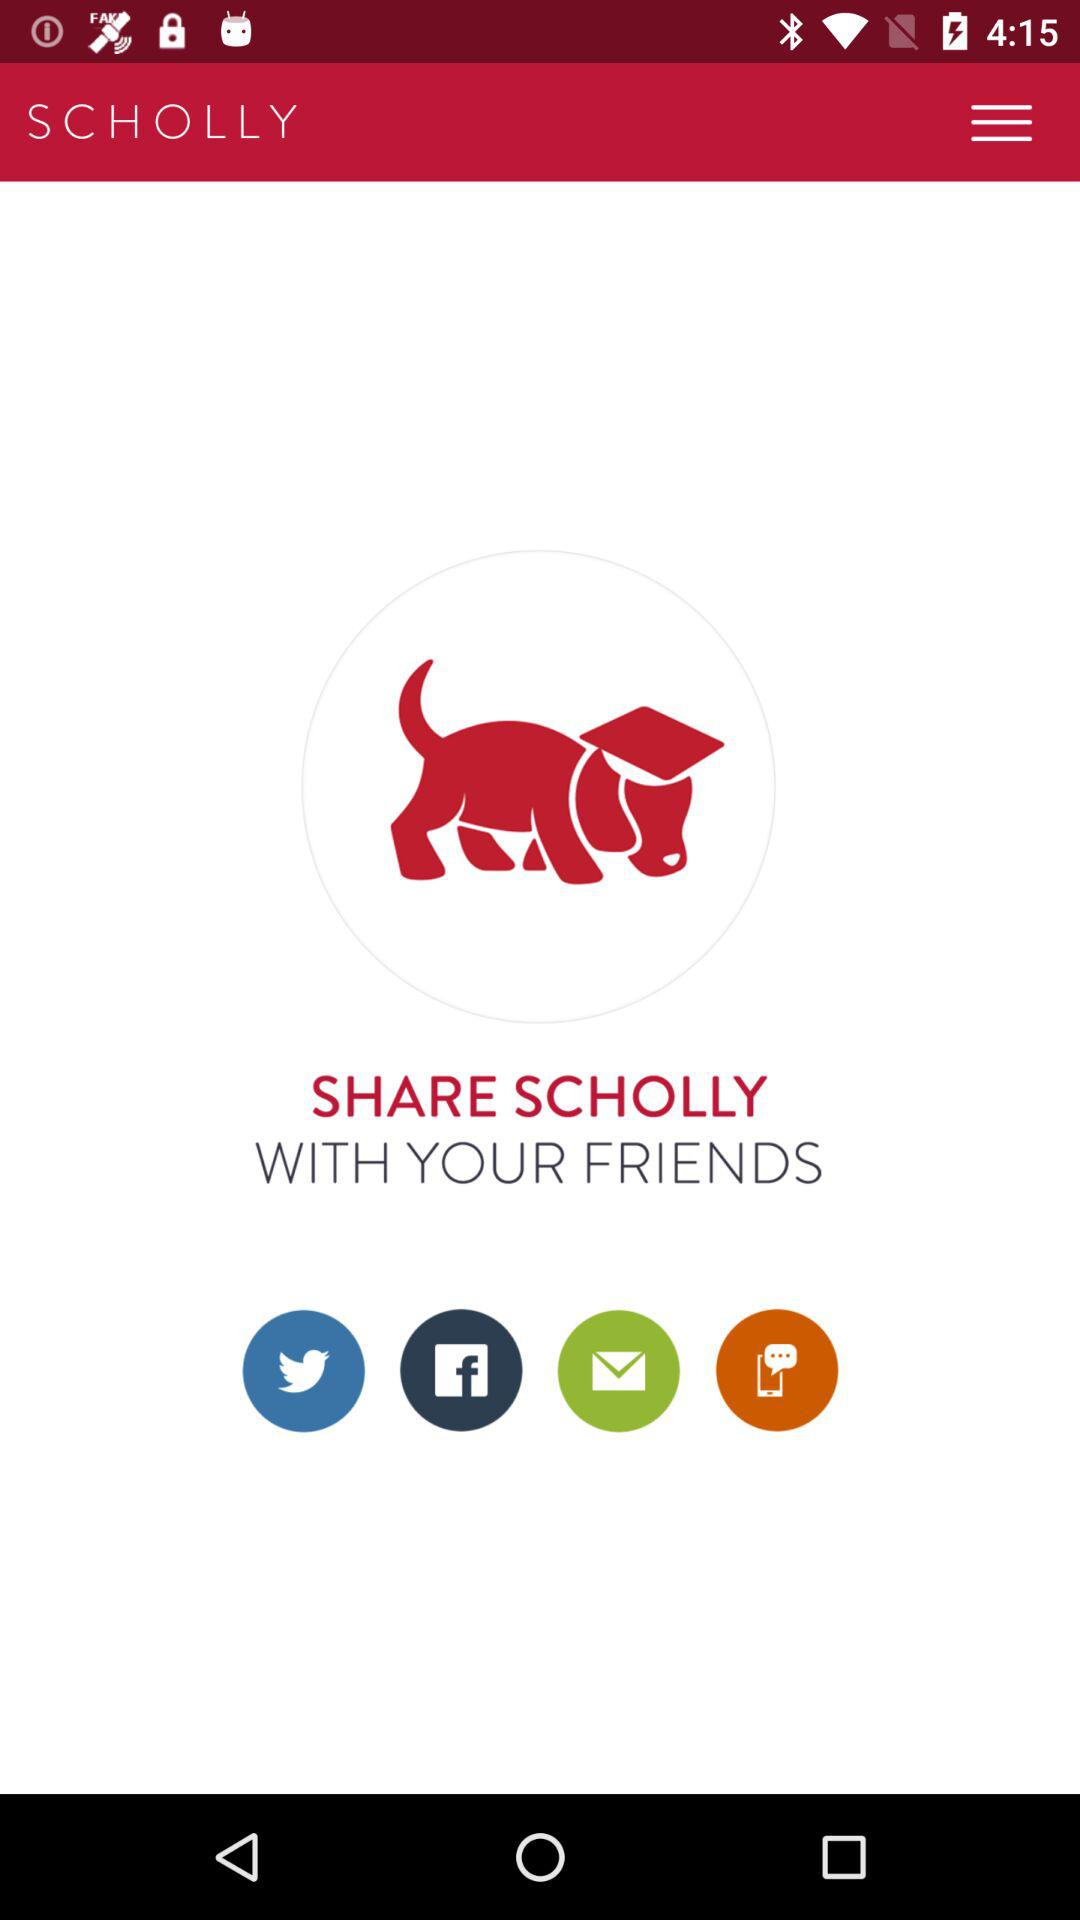Through which application can we share "SCHOLLY"? You can share "SCHOLLY" through "Twitter", "Facebook" and "Text Message". 